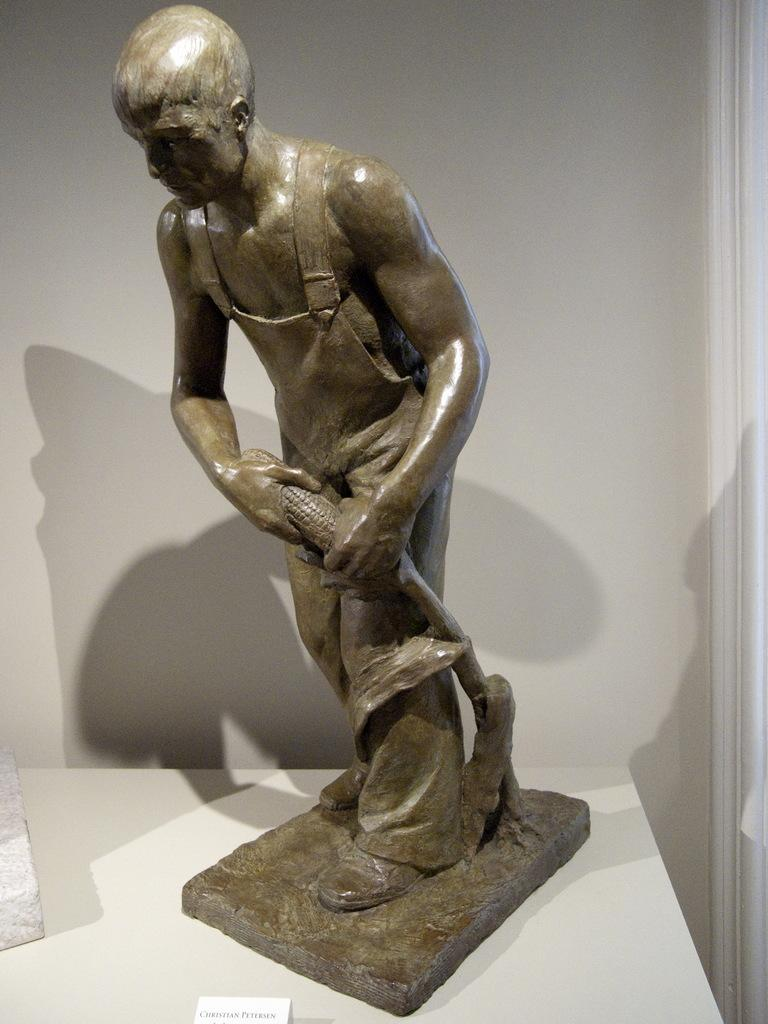What is the main subject in the image? There is a statue in the image. What is the statue placed on? The statue is on a white surface. Is there any text or information about the statue in the image? Yes, there is a nameplate in front of the statue. What can be seen behind the statue? There is a white color wall behind the statue. What does the grandmother say about the statue in the image? There is no mention of a grandmother in the image, and the statue does not have the ability to speak. 